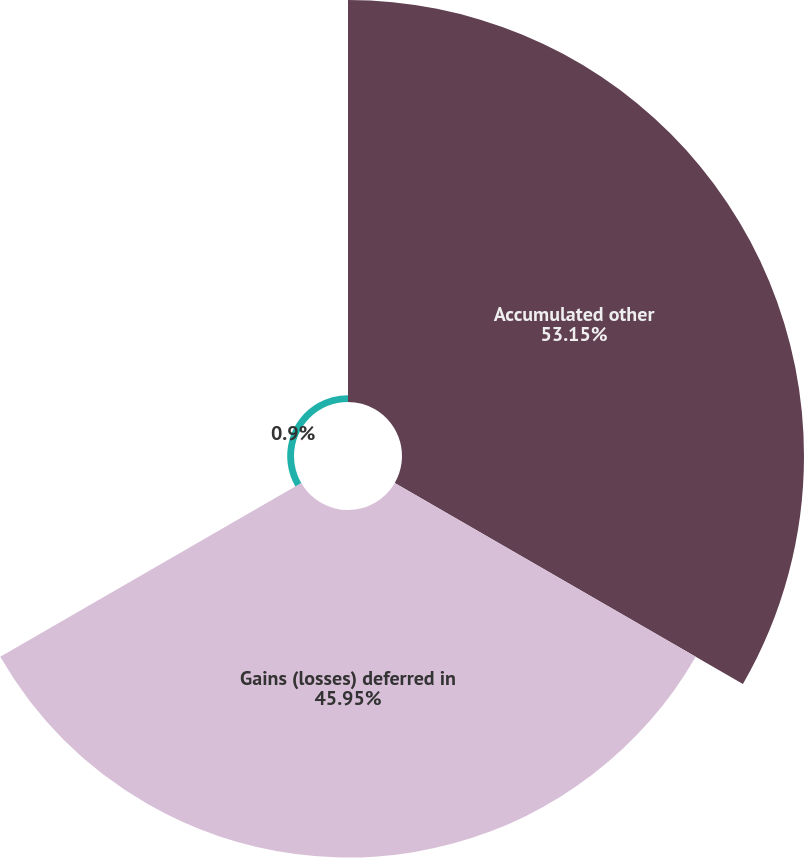<chart> <loc_0><loc_0><loc_500><loc_500><pie_chart><fcel>Accumulated other<fcel>Gains (losses) deferred in<fcel>Unnamed: 2<nl><fcel>53.15%<fcel>45.95%<fcel>0.9%<nl></chart> 